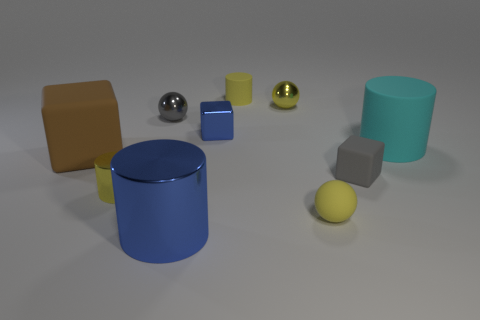The other small object that is the same shape as the gray matte object is what color?
Your answer should be very brief. Blue. There is a thing that is to the left of the yellow cylinder that is in front of the cyan object; what is it made of?
Offer a terse response. Rubber. There is a yellow metallic thing behind the brown rubber thing; does it have the same shape as the small gray object that is to the left of the yellow matte cylinder?
Provide a short and direct response. Yes. There is a yellow object that is both on the left side of the yellow shiny ball and behind the cyan cylinder; what size is it?
Ensure brevity in your answer.  Small. What number of other things are there of the same color as the small shiny cylinder?
Your response must be concise. 3. Are the yellow cylinder behind the large matte block and the large blue thing made of the same material?
Offer a terse response. No. Are there fewer big cyan matte things in front of the small gray shiny object than small yellow shiny balls on the left side of the brown thing?
Your response must be concise. No. There is another tiny ball that is the same color as the rubber ball; what is its material?
Offer a very short reply. Metal. There is a rubber thing to the left of the small yellow metallic thing that is left of the blue metallic cylinder; what number of yellow rubber spheres are in front of it?
Offer a very short reply. 1. There is a tiny yellow metal sphere; how many tiny matte things are in front of it?
Keep it short and to the point. 2. 